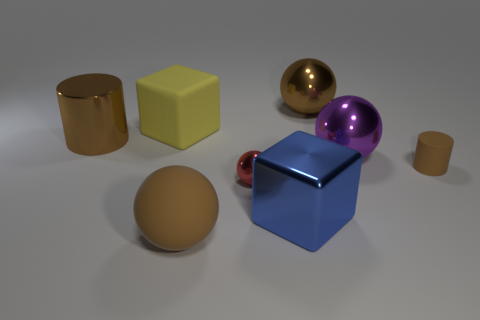How many small spheres are the same color as the big rubber cube?
Offer a terse response. 0. Is the tiny ball made of the same material as the large purple ball?
Offer a very short reply. Yes. There is a large cube that is right of the red sphere; what number of large yellow things are on the right side of it?
Provide a succinct answer. 0. Do the matte cylinder and the purple shiny object have the same size?
Offer a terse response. No. How many big blue blocks have the same material as the large blue object?
Offer a very short reply. 0. What size is the other matte thing that is the same shape as the big blue object?
Offer a terse response. Large. There is a small thing right of the brown metal sphere; is it the same shape as the purple object?
Your response must be concise. No. The big brown thing that is behind the rubber object behind the large brown cylinder is what shape?
Make the answer very short. Sphere. Is there any other thing that is the same shape as the large purple metallic thing?
Your response must be concise. Yes. The other object that is the same shape as the big blue metal thing is what color?
Offer a very short reply. Yellow. 